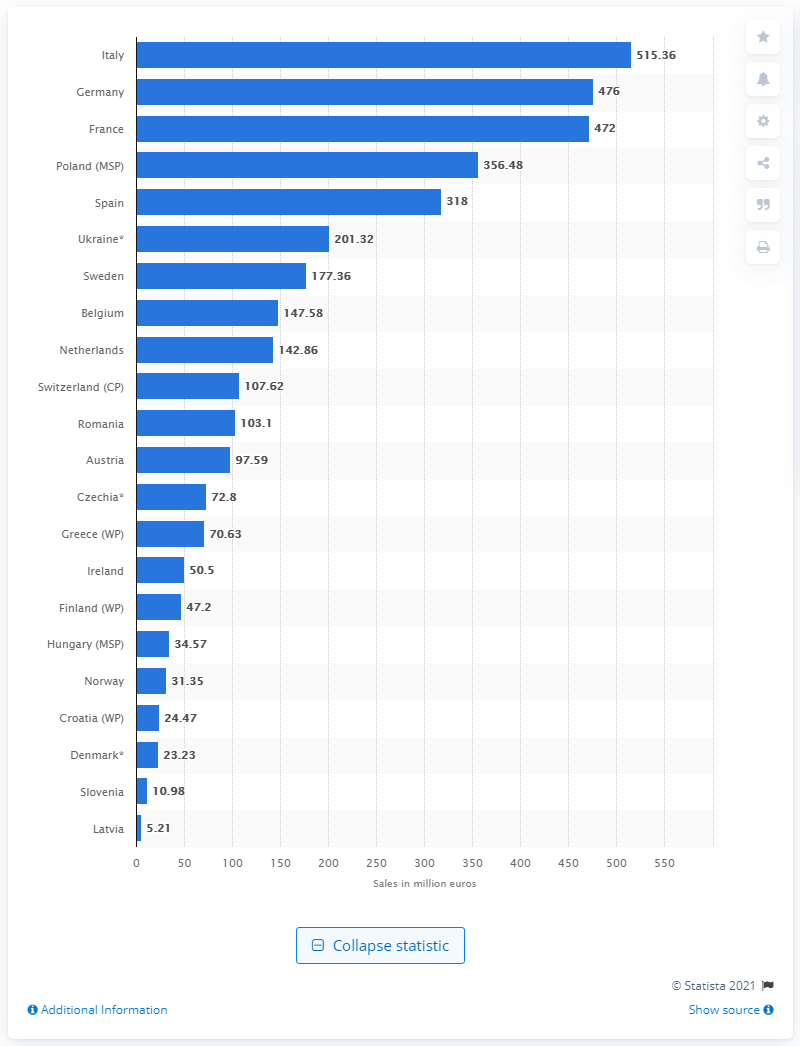Draw attention to some important aspects in this diagram. Latvia had the lowest sales of analgesic products in self-medication among European countries. In 2017, Italy was the leading country in terms of sales of analgesic products. 